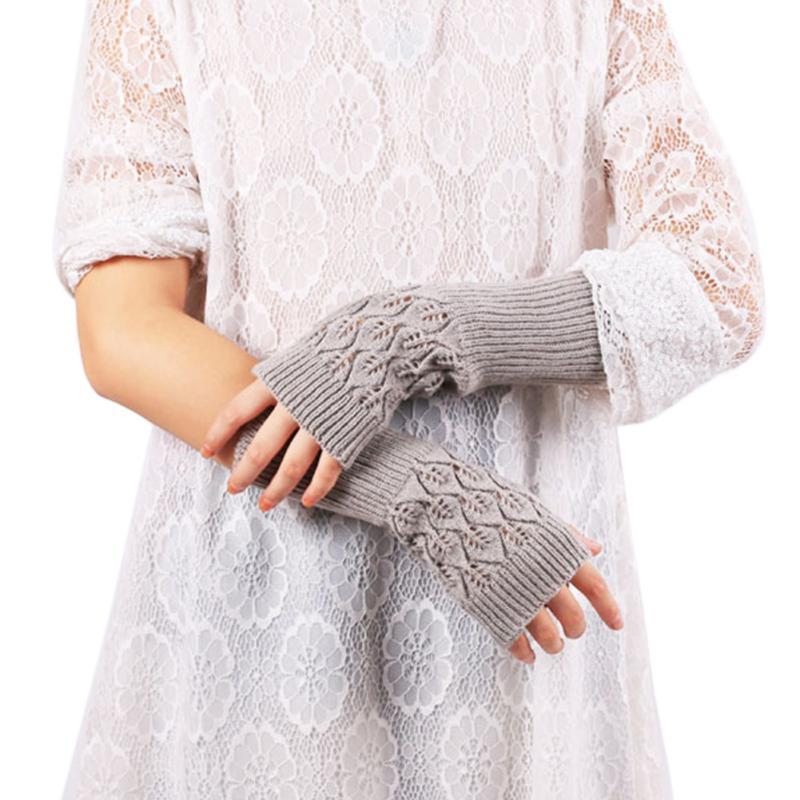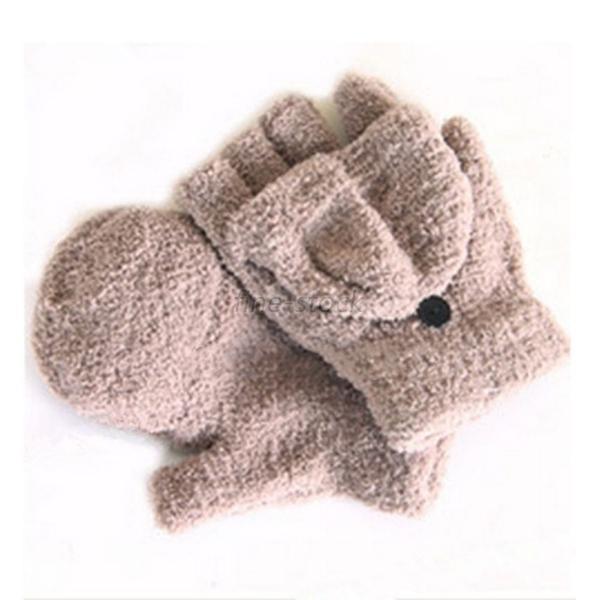The first image is the image on the left, the second image is the image on the right. Examine the images to the left and right. Is the description "There's a set of gloves that are not being worn." accurate? Answer yes or no. Yes. The first image is the image on the left, the second image is the image on the right. Evaluate the accuracy of this statement regarding the images: "There are a total of 2 hand models present wearing gloves.". Is it true? Answer yes or no. No. 